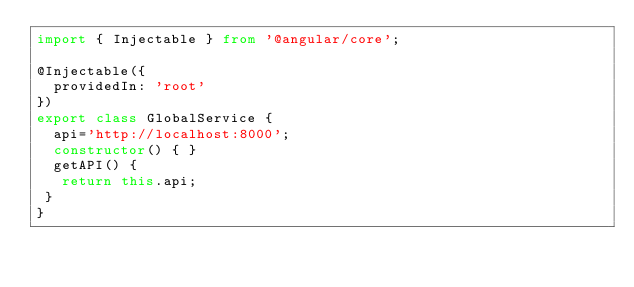Convert code to text. <code><loc_0><loc_0><loc_500><loc_500><_TypeScript_>import { Injectable } from '@angular/core';

@Injectable({
  providedIn: 'root'
})
export class GlobalService {
  api='http://localhost:8000';
  constructor() { }
  getAPI() {
   return this.api;
 }
}
</code> 